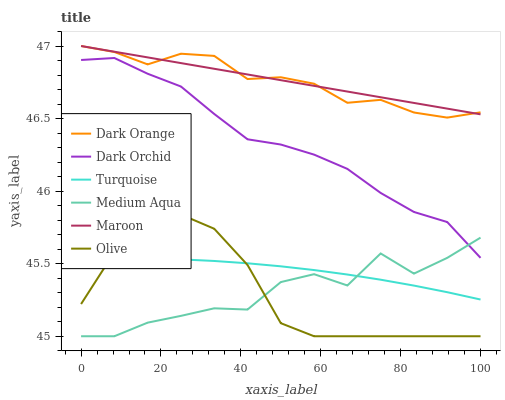Does Olive have the minimum area under the curve?
Answer yes or no. Yes. Does Maroon have the maximum area under the curve?
Answer yes or no. Yes. Does Turquoise have the minimum area under the curve?
Answer yes or no. No. Does Turquoise have the maximum area under the curve?
Answer yes or no. No. Is Maroon the smoothest?
Answer yes or no. Yes. Is Medium Aqua the roughest?
Answer yes or no. Yes. Is Turquoise the smoothest?
Answer yes or no. No. Is Turquoise the roughest?
Answer yes or no. No. Does Medium Aqua have the lowest value?
Answer yes or no. Yes. Does Turquoise have the lowest value?
Answer yes or no. No. Does Maroon have the highest value?
Answer yes or no. Yes. Does Turquoise have the highest value?
Answer yes or no. No. Is Turquoise less than Dark Orchid?
Answer yes or no. Yes. Is Dark Orchid greater than Turquoise?
Answer yes or no. Yes. Does Medium Aqua intersect Turquoise?
Answer yes or no. Yes. Is Medium Aqua less than Turquoise?
Answer yes or no. No. Is Medium Aqua greater than Turquoise?
Answer yes or no. No. Does Turquoise intersect Dark Orchid?
Answer yes or no. No. 